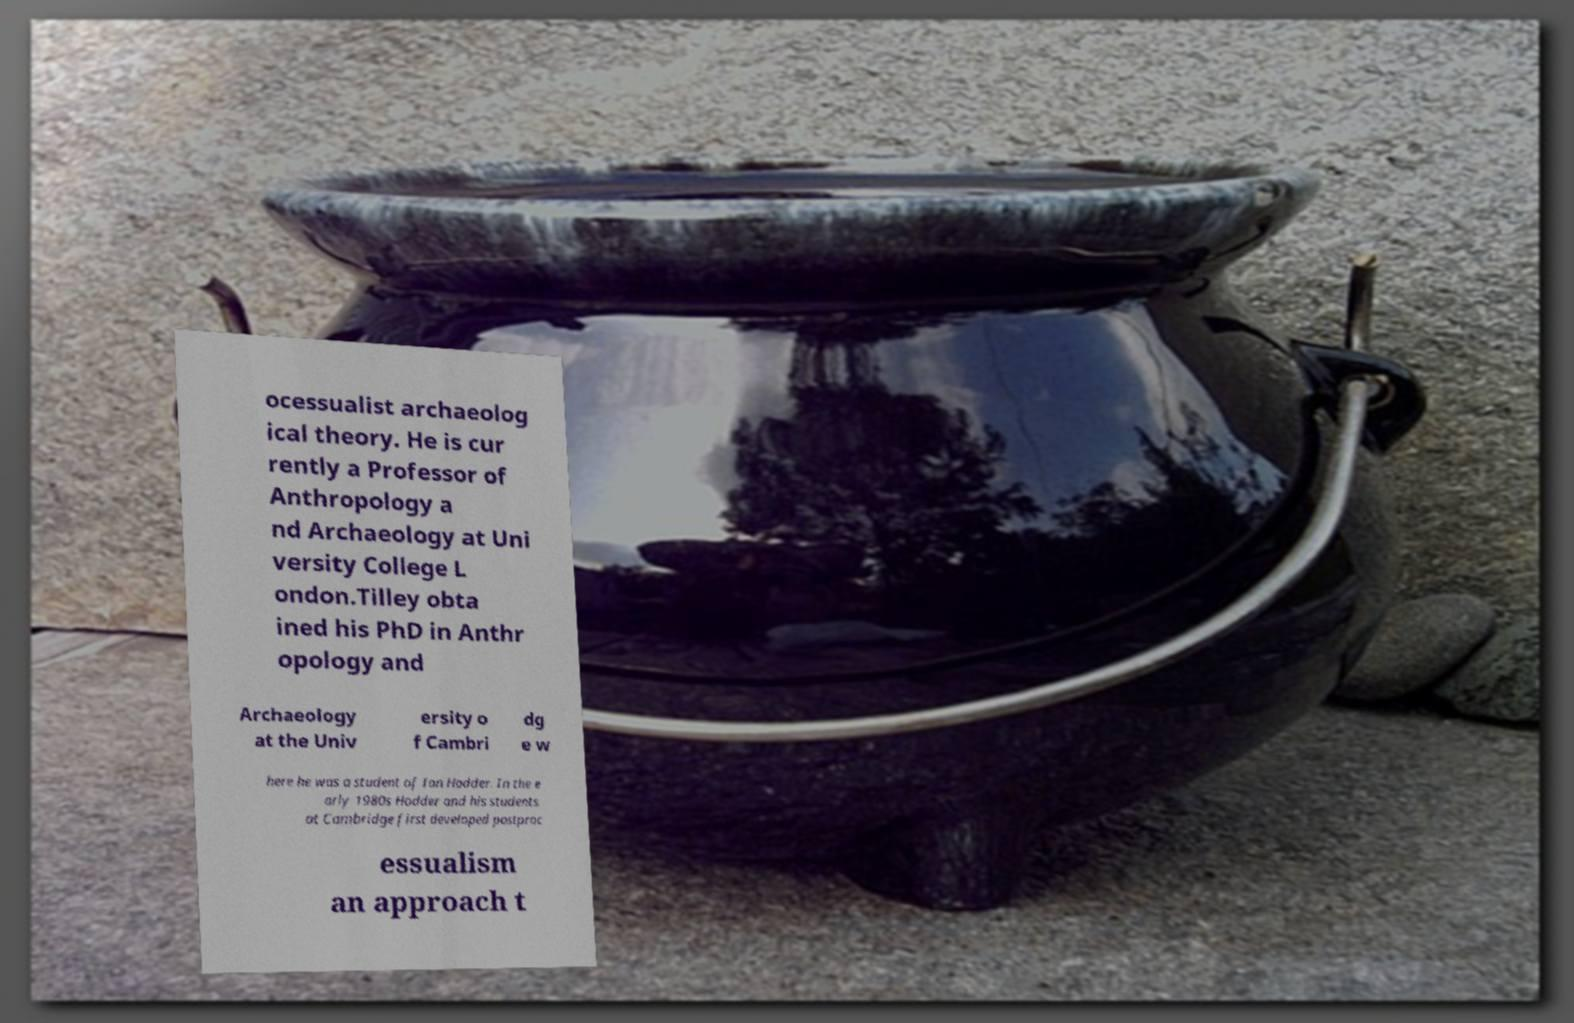For documentation purposes, I need the text within this image transcribed. Could you provide that? ocessualist archaeolog ical theory. He is cur rently a Professor of Anthropology a nd Archaeology at Uni versity College L ondon.Tilley obta ined his PhD in Anthr opology and Archaeology at the Univ ersity o f Cambri dg e w here he was a student of Ian Hodder. In the e arly 1980s Hodder and his students at Cambridge first developed postproc essualism an approach t 